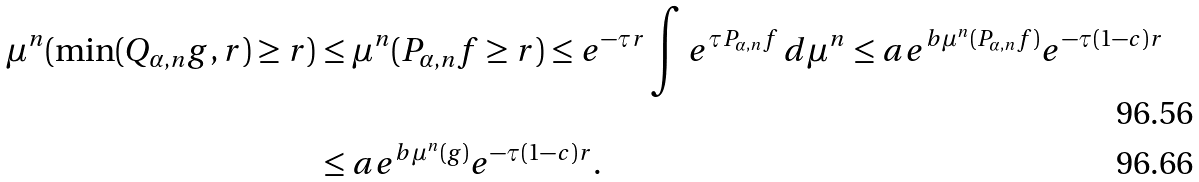Convert formula to latex. <formula><loc_0><loc_0><loc_500><loc_500>\mu ^ { n } ( \min ( Q _ { \alpha , n } g , r ) \geq r ) & \leq \mu ^ { n } ( P _ { \alpha , n } f \geq r ) \leq e ^ { - \tau r } \int e ^ { \tau P _ { \alpha , n } f } \, d \mu ^ { n } \leq a e ^ { b \mu ^ { n } ( P _ { \alpha , n } f ) } e ^ { - \tau ( 1 - c ) r } \\ & \leq a e ^ { b \mu ^ { n } ( g ) } e ^ { - \tau ( 1 - c ) r } .</formula> 